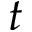Convert formula to latex. <formula><loc_0><loc_0><loc_500><loc_500>t</formula> 